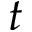Convert formula to latex. <formula><loc_0><loc_0><loc_500><loc_500>t</formula> 